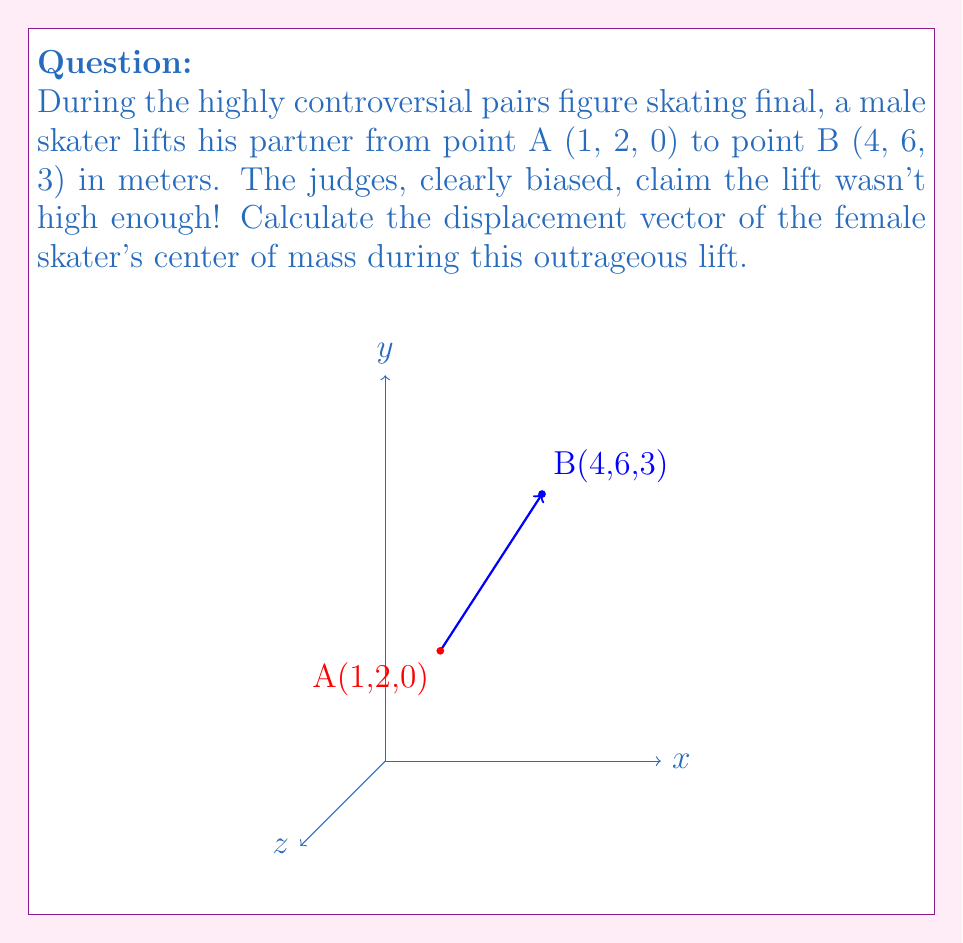Could you help me with this problem? To find the displacement vector, we need to calculate the difference between the final position (point B) and the initial position (point A).

1) Let's define the initial and final positions:
   Point A: $A = (1, 2, 0)$
   Point B: $B = (4, 6, 3)$

2) The displacement vector $\vec{d}$ is given by:
   $\vec{d} = B - A$

3) Subtracting the coordinates:
   $\vec{d} = (4-1, 6-2, 3-0)$

4) Simplifying:
   $\vec{d} = (3, 4, 3)$

This vector represents the change in position of the female skater's center of mass during the lift. The components indicate:
- 3 meters in the x-direction
- 4 meters in the y-direction
- 3 meters in the z-direction (vertical lift)

Despite the judges' claims, the lift raised the skater by 3 meters vertically!
Answer: $\vec{d} = (3, 4, 3)$ 